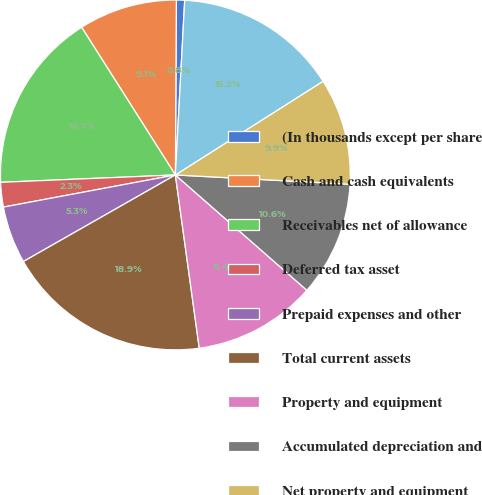<chart> <loc_0><loc_0><loc_500><loc_500><pie_chart><fcel>(In thousands except per share<fcel>Cash and cash equivalents<fcel>Receivables net of allowance<fcel>Deferred tax asset<fcel>Prepaid expenses and other<fcel>Total current assets<fcel>Property and equipment<fcel>Accumulated depreciation and<fcel>Net property and equipment<fcel>Goodwill<nl><fcel>0.76%<fcel>9.09%<fcel>16.67%<fcel>2.27%<fcel>5.3%<fcel>18.94%<fcel>11.36%<fcel>10.61%<fcel>9.85%<fcel>15.15%<nl></chart> 